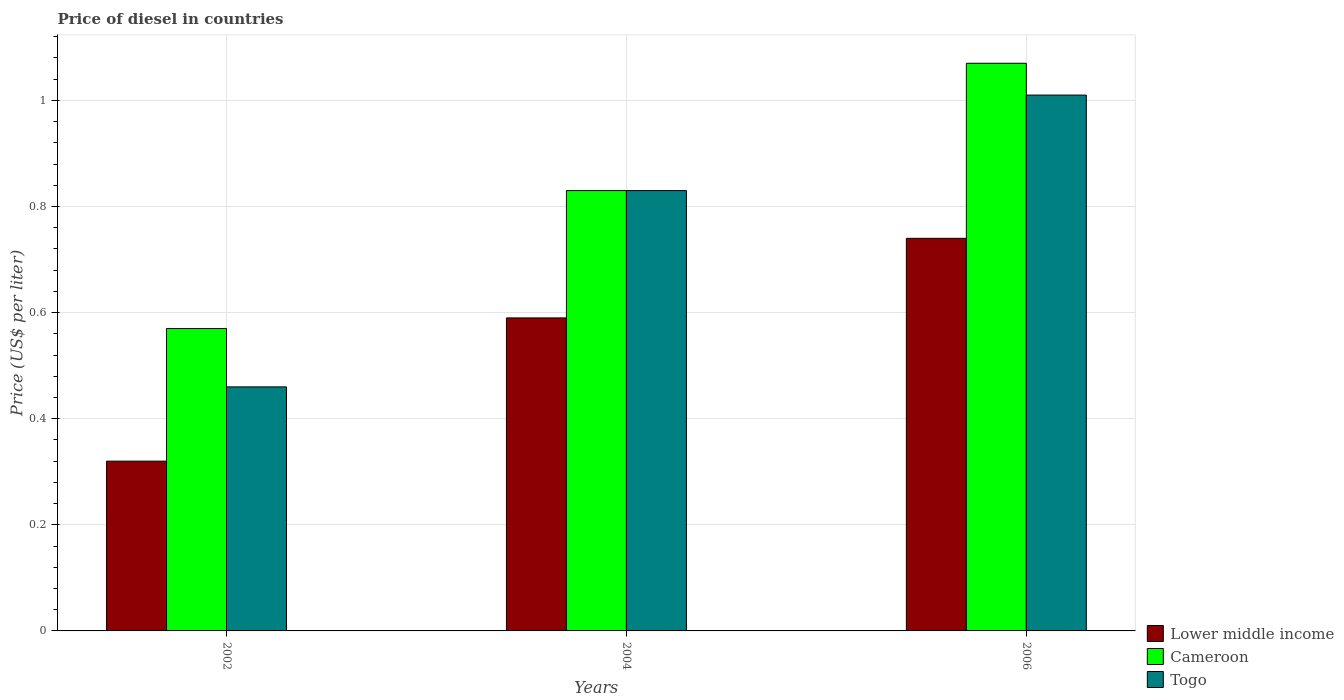How many groups of bars are there?
Provide a succinct answer. 3. Are the number of bars per tick equal to the number of legend labels?
Offer a terse response. Yes. How many bars are there on the 2nd tick from the right?
Provide a short and direct response. 3. What is the label of the 1st group of bars from the left?
Provide a short and direct response. 2002. What is the price of diesel in Cameroon in 2004?
Your answer should be compact. 0.83. Across all years, what is the maximum price of diesel in Cameroon?
Offer a terse response. 1.07. Across all years, what is the minimum price of diesel in Lower middle income?
Offer a terse response. 0.32. In which year was the price of diesel in Lower middle income maximum?
Ensure brevity in your answer.  2006. In which year was the price of diesel in Togo minimum?
Your answer should be compact. 2002. What is the total price of diesel in Cameroon in the graph?
Provide a short and direct response. 2.47. What is the difference between the price of diesel in Cameroon in 2002 and that in 2004?
Offer a very short reply. -0.26. What is the difference between the price of diesel in Lower middle income in 2002 and the price of diesel in Togo in 2004?
Provide a succinct answer. -0.51. What is the average price of diesel in Togo per year?
Your answer should be very brief. 0.77. In the year 2004, what is the difference between the price of diesel in Togo and price of diesel in Lower middle income?
Your answer should be very brief. 0.24. In how many years, is the price of diesel in Lower middle income greater than 0.9600000000000001 US$?
Give a very brief answer. 0. What is the ratio of the price of diesel in Lower middle income in 2004 to that in 2006?
Ensure brevity in your answer.  0.8. What is the difference between the highest and the second highest price of diesel in Togo?
Offer a very short reply. 0.18. What is the difference between the highest and the lowest price of diesel in Cameroon?
Ensure brevity in your answer.  0.5. In how many years, is the price of diesel in Lower middle income greater than the average price of diesel in Lower middle income taken over all years?
Offer a very short reply. 2. Is the sum of the price of diesel in Cameroon in 2004 and 2006 greater than the maximum price of diesel in Lower middle income across all years?
Give a very brief answer. Yes. What does the 3rd bar from the left in 2004 represents?
Keep it short and to the point. Togo. What does the 2nd bar from the right in 2002 represents?
Your answer should be compact. Cameroon. Is it the case that in every year, the sum of the price of diesel in Cameroon and price of diesel in Lower middle income is greater than the price of diesel in Togo?
Provide a succinct answer. Yes. How many years are there in the graph?
Offer a very short reply. 3. What is the difference between two consecutive major ticks on the Y-axis?
Give a very brief answer. 0.2. Where does the legend appear in the graph?
Provide a succinct answer. Bottom right. How are the legend labels stacked?
Ensure brevity in your answer.  Vertical. What is the title of the graph?
Your answer should be compact. Price of diesel in countries. Does "Korea (Democratic)" appear as one of the legend labels in the graph?
Ensure brevity in your answer.  No. What is the label or title of the Y-axis?
Offer a very short reply. Price (US$ per liter). What is the Price (US$ per liter) of Lower middle income in 2002?
Ensure brevity in your answer.  0.32. What is the Price (US$ per liter) in Cameroon in 2002?
Provide a short and direct response. 0.57. What is the Price (US$ per liter) in Togo in 2002?
Ensure brevity in your answer.  0.46. What is the Price (US$ per liter) in Lower middle income in 2004?
Offer a terse response. 0.59. What is the Price (US$ per liter) in Cameroon in 2004?
Your answer should be very brief. 0.83. What is the Price (US$ per liter) of Togo in 2004?
Offer a terse response. 0.83. What is the Price (US$ per liter) of Lower middle income in 2006?
Keep it short and to the point. 0.74. What is the Price (US$ per liter) in Cameroon in 2006?
Give a very brief answer. 1.07. What is the Price (US$ per liter) of Togo in 2006?
Provide a succinct answer. 1.01. Across all years, what is the maximum Price (US$ per liter) of Lower middle income?
Offer a terse response. 0.74. Across all years, what is the maximum Price (US$ per liter) of Cameroon?
Offer a terse response. 1.07. Across all years, what is the minimum Price (US$ per liter) of Lower middle income?
Provide a succinct answer. 0.32. Across all years, what is the minimum Price (US$ per liter) in Cameroon?
Offer a very short reply. 0.57. Across all years, what is the minimum Price (US$ per liter) of Togo?
Give a very brief answer. 0.46. What is the total Price (US$ per liter) of Lower middle income in the graph?
Offer a terse response. 1.65. What is the total Price (US$ per liter) in Cameroon in the graph?
Your answer should be compact. 2.47. What is the total Price (US$ per liter) of Togo in the graph?
Keep it short and to the point. 2.3. What is the difference between the Price (US$ per liter) of Lower middle income in 2002 and that in 2004?
Make the answer very short. -0.27. What is the difference between the Price (US$ per liter) in Cameroon in 2002 and that in 2004?
Make the answer very short. -0.26. What is the difference between the Price (US$ per liter) of Togo in 2002 and that in 2004?
Your answer should be very brief. -0.37. What is the difference between the Price (US$ per liter) of Lower middle income in 2002 and that in 2006?
Give a very brief answer. -0.42. What is the difference between the Price (US$ per liter) in Cameroon in 2002 and that in 2006?
Offer a very short reply. -0.5. What is the difference between the Price (US$ per liter) of Togo in 2002 and that in 2006?
Your answer should be very brief. -0.55. What is the difference between the Price (US$ per liter) in Lower middle income in 2004 and that in 2006?
Keep it short and to the point. -0.15. What is the difference between the Price (US$ per liter) of Cameroon in 2004 and that in 2006?
Offer a terse response. -0.24. What is the difference between the Price (US$ per liter) in Togo in 2004 and that in 2006?
Provide a succinct answer. -0.18. What is the difference between the Price (US$ per liter) of Lower middle income in 2002 and the Price (US$ per liter) of Cameroon in 2004?
Offer a terse response. -0.51. What is the difference between the Price (US$ per liter) of Lower middle income in 2002 and the Price (US$ per liter) of Togo in 2004?
Your response must be concise. -0.51. What is the difference between the Price (US$ per liter) of Cameroon in 2002 and the Price (US$ per liter) of Togo in 2004?
Give a very brief answer. -0.26. What is the difference between the Price (US$ per liter) of Lower middle income in 2002 and the Price (US$ per liter) of Cameroon in 2006?
Your response must be concise. -0.75. What is the difference between the Price (US$ per liter) in Lower middle income in 2002 and the Price (US$ per liter) in Togo in 2006?
Offer a terse response. -0.69. What is the difference between the Price (US$ per liter) in Cameroon in 2002 and the Price (US$ per liter) in Togo in 2006?
Your answer should be compact. -0.44. What is the difference between the Price (US$ per liter) of Lower middle income in 2004 and the Price (US$ per liter) of Cameroon in 2006?
Give a very brief answer. -0.48. What is the difference between the Price (US$ per liter) of Lower middle income in 2004 and the Price (US$ per liter) of Togo in 2006?
Your response must be concise. -0.42. What is the difference between the Price (US$ per liter) of Cameroon in 2004 and the Price (US$ per liter) of Togo in 2006?
Your response must be concise. -0.18. What is the average Price (US$ per liter) of Lower middle income per year?
Your response must be concise. 0.55. What is the average Price (US$ per liter) of Cameroon per year?
Provide a short and direct response. 0.82. What is the average Price (US$ per liter) of Togo per year?
Your response must be concise. 0.77. In the year 2002, what is the difference between the Price (US$ per liter) in Lower middle income and Price (US$ per liter) in Cameroon?
Your answer should be compact. -0.25. In the year 2002, what is the difference between the Price (US$ per liter) in Lower middle income and Price (US$ per liter) in Togo?
Your answer should be very brief. -0.14. In the year 2002, what is the difference between the Price (US$ per liter) of Cameroon and Price (US$ per liter) of Togo?
Ensure brevity in your answer.  0.11. In the year 2004, what is the difference between the Price (US$ per liter) in Lower middle income and Price (US$ per liter) in Cameroon?
Keep it short and to the point. -0.24. In the year 2004, what is the difference between the Price (US$ per liter) of Lower middle income and Price (US$ per liter) of Togo?
Your answer should be compact. -0.24. In the year 2006, what is the difference between the Price (US$ per liter) in Lower middle income and Price (US$ per liter) in Cameroon?
Your response must be concise. -0.33. In the year 2006, what is the difference between the Price (US$ per liter) of Lower middle income and Price (US$ per liter) of Togo?
Provide a short and direct response. -0.27. In the year 2006, what is the difference between the Price (US$ per liter) of Cameroon and Price (US$ per liter) of Togo?
Your answer should be very brief. 0.06. What is the ratio of the Price (US$ per liter) in Lower middle income in 2002 to that in 2004?
Provide a succinct answer. 0.54. What is the ratio of the Price (US$ per liter) of Cameroon in 2002 to that in 2004?
Your response must be concise. 0.69. What is the ratio of the Price (US$ per liter) of Togo in 2002 to that in 2004?
Your answer should be very brief. 0.55. What is the ratio of the Price (US$ per liter) of Lower middle income in 2002 to that in 2006?
Your response must be concise. 0.43. What is the ratio of the Price (US$ per liter) of Cameroon in 2002 to that in 2006?
Make the answer very short. 0.53. What is the ratio of the Price (US$ per liter) in Togo in 2002 to that in 2006?
Your answer should be very brief. 0.46. What is the ratio of the Price (US$ per liter) of Lower middle income in 2004 to that in 2006?
Make the answer very short. 0.8. What is the ratio of the Price (US$ per liter) in Cameroon in 2004 to that in 2006?
Provide a short and direct response. 0.78. What is the ratio of the Price (US$ per liter) of Togo in 2004 to that in 2006?
Your answer should be compact. 0.82. What is the difference between the highest and the second highest Price (US$ per liter) of Cameroon?
Keep it short and to the point. 0.24. What is the difference between the highest and the second highest Price (US$ per liter) of Togo?
Offer a very short reply. 0.18. What is the difference between the highest and the lowest Price (US$ per liter) of Lower middle income?
Provide a short and direct response. 0.42. What is the difference between the highest and the lowest Price (US$ per liter) in Cameroon?
Keep it short and to the point. 0.5. What is the difference between the highest and the lowest Price (US$ per liter) of Togo?
Your answer should be compact. 0.55. 